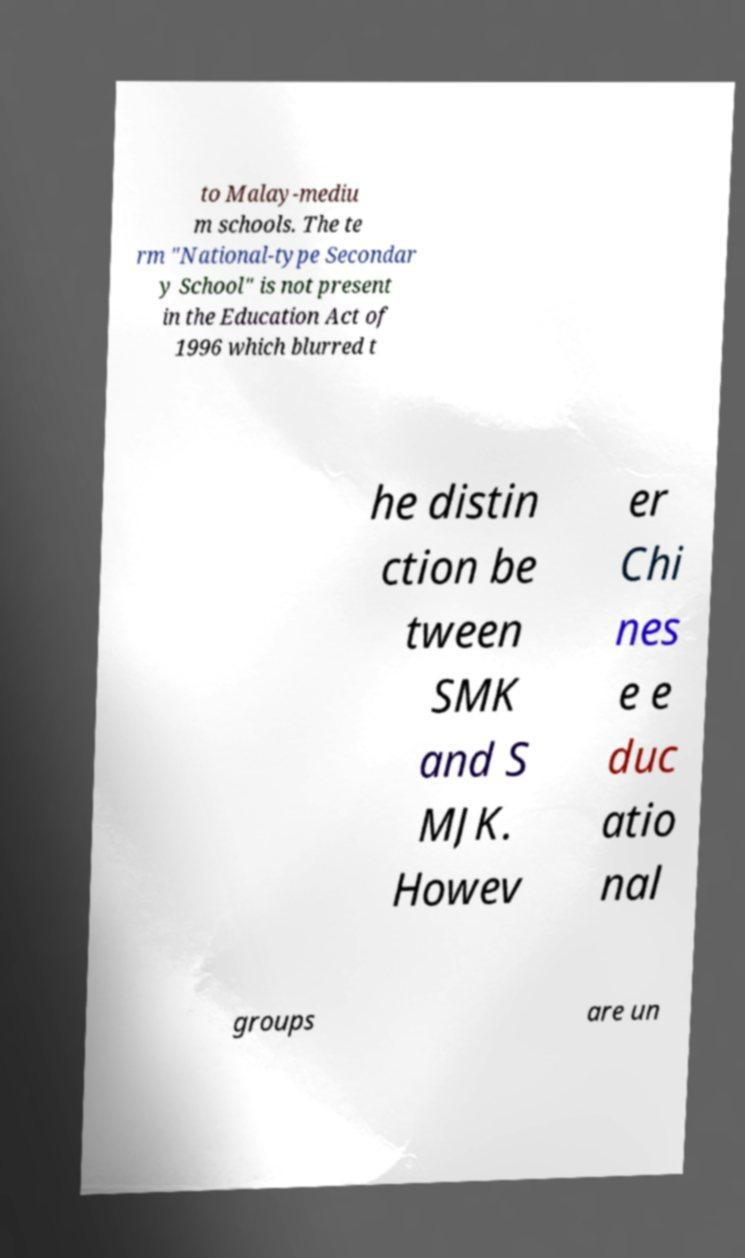I need the written content from this picture converted into text. Can you do that? to Malay-mediu m schools. The te rm "National-type Secondar y School" is not present in the Education Act of 1996 which blurred t he distin ction be tween SMK and S MJK. Howev er Chi nes e e duc atio nal groups are un 